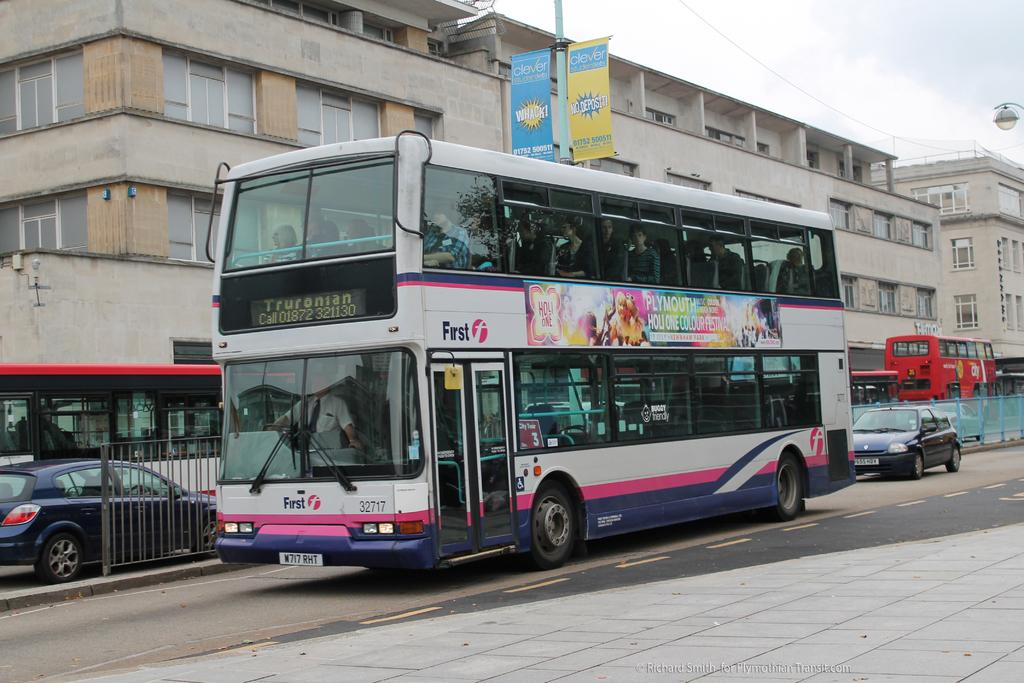Provide a one-sentence caption for the provided image. The bus has the company name First on the side of it. 